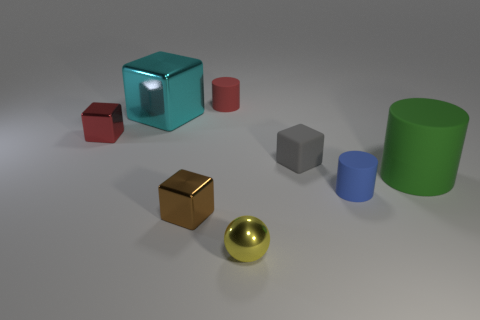Subtract all yellow blocks. Subtract all blue cylinders. How many blocks are left? 4 Add 1 big yellow matte balls. How many objects exist? 9 Subtract all cylinders. How many objects are left? 5 Subtract 0 green blocks. How many objects are left? 8 Subtract all large red metallic cubes. Subtract all gray rubber things. How many objects are left? 7 Add 1 small rubber things. How many small rubber things are left? 4 Add 1 green things. How many green things exist? 2 